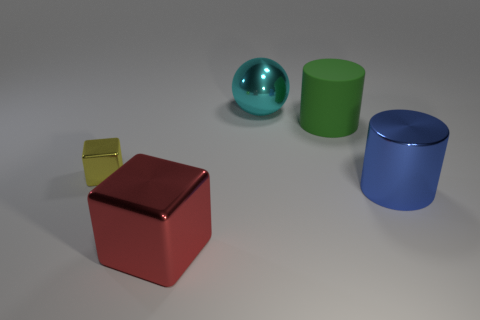There is a large metallic object that is behind the tiny yellow thing; is it the same shape as the tiny object?
Provide a succinct answer. No. How many large metallic objects are on the right side of the large red cube and left of the green cylinder?
Provide a short and direct response. 1. What number of other things are the same size as the green cylinder?
Provide a succinct answer. 3. Are there an equal number of blue metallic cylinders that are on the left side of the large metal sphere and large green metallic cylinders?
Provide a short and direct response. Yes. What is the material of the large thing that is in front of the large green matte cylinder and left of the metallic cylinder?
Offer a terse response. Metal. The large rubber cylinder has what color?
Your response must be concise. Green. How many other things are the same shape as the green rubber object?
Your answer should be very brief. 1. Is the number of big green cylinders that are in front of the tiny yellow shiny cube the same as the number of green things to the right of the big cyan metal thing?
Provide a short and direct response. No. What is the material of the cyan ball?
Ensure brevity in your answer.  Metal. What material is the large cylinder behind the yellow metal cube?
Offer a terse response. Rubber. 